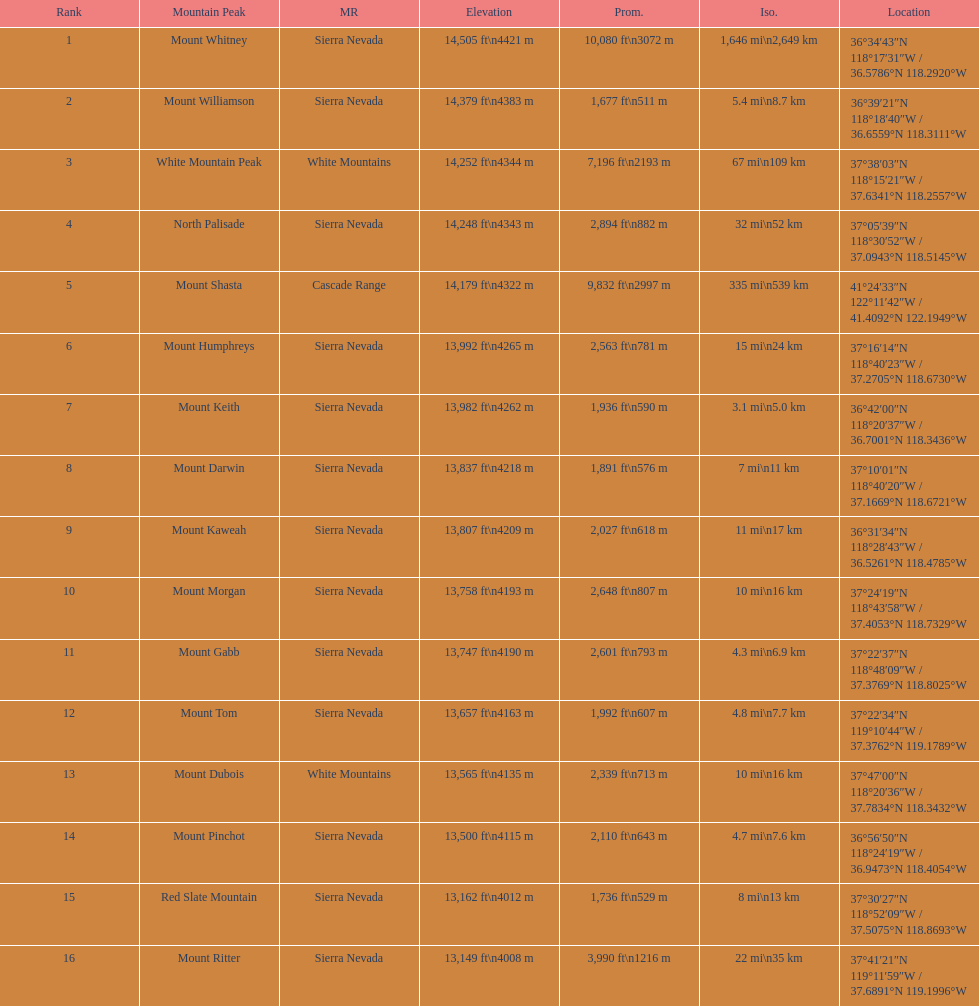How much taller is the mountain peak of mount williamson than that of mount keith? 397 ft. 